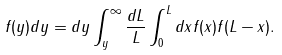<formula> <loc_0><loc_0><loc_500><loc_500>f ( y ) d y = d y \int _ { y } ^ { \infty } \frac { d L } { L } \int _ { 0 } ^ { L } d x f ( x ) f ( L - x ) .</formula> 